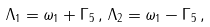<formula> <loc_0><loc_0><loc_500><loc_500>\Lambda _ { 1 } = \omega _ { 1 } + \Gamma _ { 5 } \, , \, \Lambda _ { 2 } = \omega _ { 1 } - \Gamma _ { 5 } \, ,</formula> 